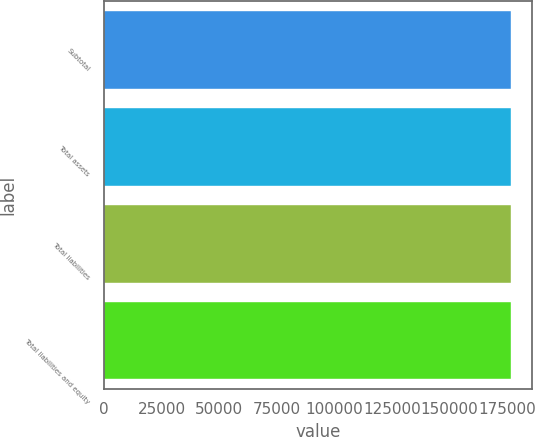<chart> <loc_0><loc_0><loc_500><loc_500><bar_chart><fcel>Subtotal<fcel>Total assets<fcel>Total liabilities<fcel>Total liabilities and equity<nl><fcel>176881<fcel>176881<fcel>176881<fcel>176881<nl></chart> 